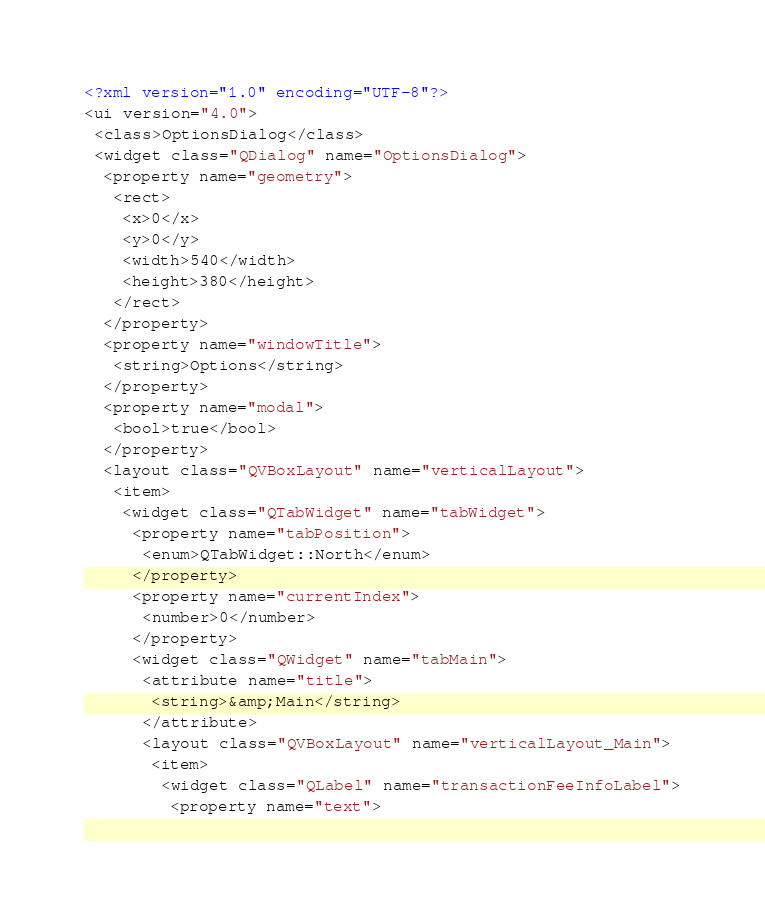<code> <loc_0><loc_0><loc_500><loc_500><_XML_><?xml version="1.0" encoding="UTF-8"?>
<ui version="4.0">
 <class>OptionsDialog</class>
 <widget class="QDialog" name="OptionsDialog">
  <property name="geometry">
   <rect>
    <x>0</x>
    <y>0</y>
    <width>540</width>
    <height>380</height>
   </rect>
  </property>
  <property name="windowTitle">
   <string>Options</string>
  </property>
  <property name="modal">
   <bool>true</bool>
  </property>
  <layout class="QVBoxLayout" name="verticalLayout">
   <item>
    <widget class="QTabWidget" name="tabWidget">
     <property name="tabPosition">
      <enum>QTabWidget::North</enum>
     </property>
     <property name="currentIndex">
      <number>0</number>
     </property>
     <widget class="QWidget" name="tabMain">
      <attribute name="title">
       <string>&amp;Main</string>
      </attribute>
      <layout class="QVBoxLayout" name="verticalLayout_Main">
       <item>
        <widget class="QLabel" name="transactionFeeInfoLabel">
         <property name="text"></code> 